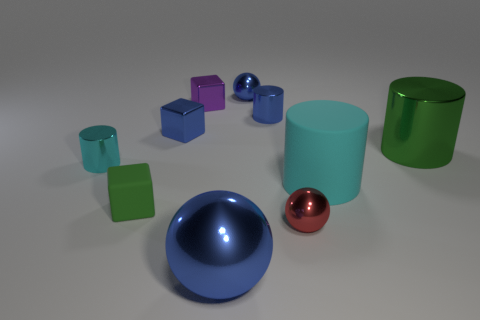What is the shape of the small object that is both in front of the cyan shiny cylinder and left of the tiny blue cylinder? The shape of the small object located in front of the cyan shiny cylinder and to the left of the tiny blue cylinder is a cube. More specifically, it's a small, purple cube that shows an interesting interplay of light and shadow on its surface. 